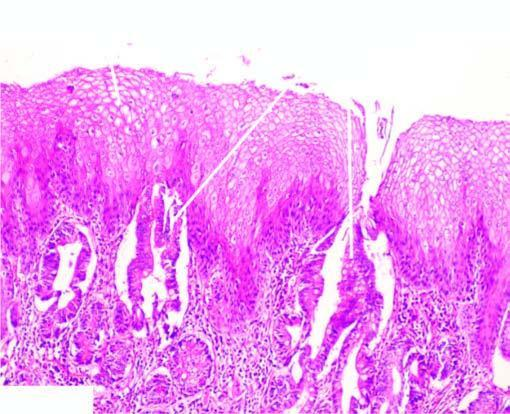what undergoes metaplastic change to columnar epithelium of intestinal type?
Answer the question using a single word or phrase. Part of the oesophagus which is normally lined by squamous epithelium 